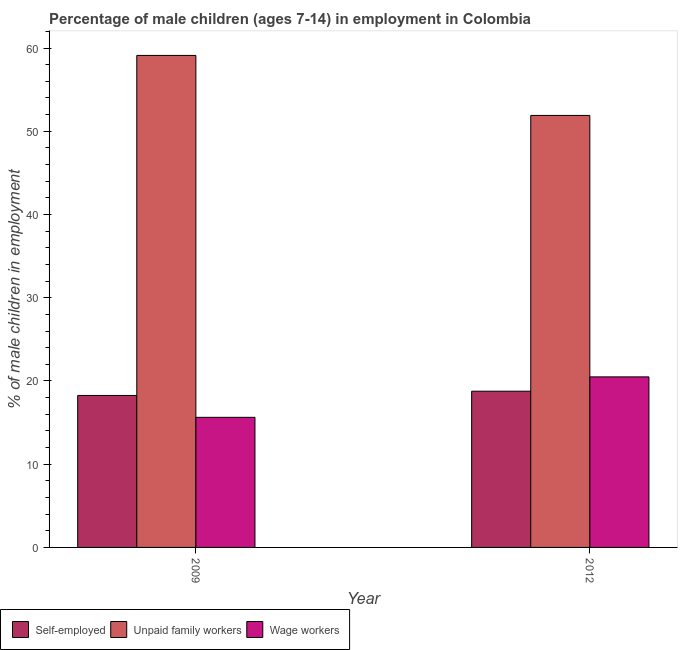How many different coloured bars are there?
Give a very brief answer. 3. How many groups of bars are there?
Your answer should be compact. 2. Are the number of bars per tick equal to the number of legend labels?
Your answer should be compact. Yes. What is the label of the 2nd group of bars from the left?
Ensure brevity in your answer.  2012. What is the percentage of children employed as wage workers in 2009?
Your answer should be very brief. 15.63. Across all years, what is the maximum percentage of children employed as unpaid family workers?
Provide a short and direct response. 59.11. Across all years, what is the minimum percentage of children employed as wage workers?
Provide a short and direct response. 15.63. In which year was the percentage of children employed as wage workers maximum?
Ensure brevity in your answer.  2012. In which year was the percentage of self employed children minimum?
Provide a short and direct response. 2009. What is the total percentage of self employed children in the graph?
Make the answer very short. 37.03. What is the difference between the percentage of children employed as wage workers in 2009 and that in 2012?
Your response must be concise. -4.86. What is the difference between the percentage of children employed as unpaid family workers in 2012 and the percentage of children employed as wage workers in 2009?
Offer a very short reply. -7.21. What is the average percentage of self employed children per year?
Give a very brief answer. 18.52. What is the ratio of the percentage of children employed as unpaid family workers in 2009 to that in 2012?
Offer a terse response. 1.14. Is the percentage of self employed children in 2009 less than that in 2012?
Provide a succinct answer. Yes. In how many years, is the percentage of children employed as wage workers greater than the average percentage of children employed as wage workers taken over all years?
Offer a very short reply. 1. What does the 2nd bar from the left in 2012 represents?
Your answer should be very brief. Unpaid family workers. What does the 2nd bar from the right in 2009 represents?
Provide a short and direct response. Unpaid family workers. How many years are there in the graph?
Ensure brevity in your answer.  2. Does the graph contain any zero values?
Provide a succinct answer. No. Where does the legend appear in the graph?
Offer a very short reply. Bottom left. What is the title of the graph?
Your answer should be compact. Percentage of male children (ages 7-14) in employment in Colombia. Does "Wage workers" appear as one of the legend labels in the graph?
Keep it short and to the point. Yes. What is the label or title of the Y-axis?
Offer a terse response. % of male children in employment. What is the % of male children in employment in Self-employed in 2009?
Give a very brief answer. 18.26. What is the % of male children in employment in Unpaid family workers in 2009?
Offer a very short reply. 59.11. What is the % of male children in employment in Wage workers in 2009?
Offer a very short reply. 15.63. What is the % of male children in employment of Self-employed in 2012?
Provide a succinct answer. 18.77. What is the % of male children in employment of Unpaid family workers in 2012?
Your answer should be very brief. 51.9. What is the % of male children in employment in Wage workers in 2012?
Offer a very short reply. 20.49. Across all years, what is the maximum % of male children in employment in Self-employed?
Provide a short and direct response. 18.77. Across all years, what is the maximum % of male children in employment of Unpaid family workers?
Your response must be concise. 59.11. Across all years, what is the maximum % of male children in employment in Wage workers?
Ensure brevity in your answer.  20.49. Across all years, what is the minimum % of male children in employment of Self-employed?
Your answer should be very brief. 18.26. Across all years, what is the minimum % of male children in employment of Unpaid family workers?
Make the answer very short. 51.9. Across all years, what is the minimum % of male children in employment of Wage workers?
Provide a short and direct response. 15.63. What is the total % of male children in employment of Self-employed in the graph?
Make the answer very short. 37.03. What is the total % of male children in employment of Unpaid family workers in the graph?
Offer a very short reply. 111.01. What is the total % of male children in employment in Wage workers in the graph?
Your answer should be compact. 36.12. What is the difference between the % of male children in employment of Self-employed in 2009 and that in 2012?
Your response must be concise. -0.51. What is the difference between the % of male children in employment in Unpaid family workers in 2009 and that in 2012?
Provide a short and direct response. 7.21. What is the difference between the % of male children in employment of Wage workers in 2009 and that in 2012?
Your answer should be compact. -4.86. What is the difference between the % of male children in employment in Self-employed in 2009 and the % of male children in employment in Unpaid family workers in 2012?
Make the answer very short. -33.64. What is the difference between the % of male children in employment of Self-employed in 2009 and the % of male children in employment of Wage workers in 2012?
Offer a terse response. -2.23. What is the difference between the % of male children in employment in Unpaid family workers in 2009 and the % of male children in employment in Wage workers in 2012?
Provide a short and direct response. 38.62. What is the average % of male children in employment of Self-employed per year?
Your response must be concise. 18.52. What is the average % of male children in employment of Unpaid family workers per year?
Your response must be concise. 55.51. What is the average % of male children in employment of Wage workers per year?
Your answer should be compact. 18.06. In the year 2009, what is the difference between the % of male children in employment in Self-employed and % of male children in employment in Unpaid family workers?
Your answer should be very brief. -40.85. In the year 2009, what is the difference between the % of male children in employment of Self-employed and % of male children in employment of Wage workers?
Provide a short and direct response. 2.63. In the year 2009, what is the difference between the % of male children in employment of Unpaid family workers and % of male children in employment of Wage workers?
Your response must be concise. 43.48. In the year 2012, what is the difference between the % of male children in employment of Self-employed and % of male children in employment of Unpaid family workers?
Keep it short and to the point. -33.13. In the year 2012, what is the difference between the % of male children in employment of Self-employed and % of male children in employment of Wage workers?
Your response must be concise. -1.72. In the year 2012, what is the difference between the % of male children in employment of Unpaid family workers and % of male children in employment of Wage workers?
Ensure brevity in your answer.  31.41. What is the ratio of the % of male children in employment of Self-employed in 2009 to that in 2012?
Your answer should be compact. 0.97. What is the ratio of the % of male children in employment of Unpaid family workers in 2009 to that in 2012?
Provide a succinct answer. 1.14. What is the ratio of the % of male children in employment of Wage workers in 2009 to that in 2012?
Ensure brevity in your answer.  0.76. What is the difference between the highest and the second highest % of male children in employment in Self-employed?
Provide a succinct answer. 0.51. What is the difference between the highest and the second highest % of male children in employment of Unpaid family workers?
Give a very brief answer. 7.21. What is the difference between the highest and the second highest % of male children in employment in Wage workers?
Your answer should be compact. 4.86. What is the difference between the highest and the lowest % of male children in employment in Self-employed?
Give a very brief answer. 0.51. What is the difference between the highest and the lowest % of male children in employment in Unpaid family workers?
Your answer should be compact. 7.21. What is the difference between the highest and the lowest % of male children in employment of Wage workers?
Offer a very short reply. 4.86. 